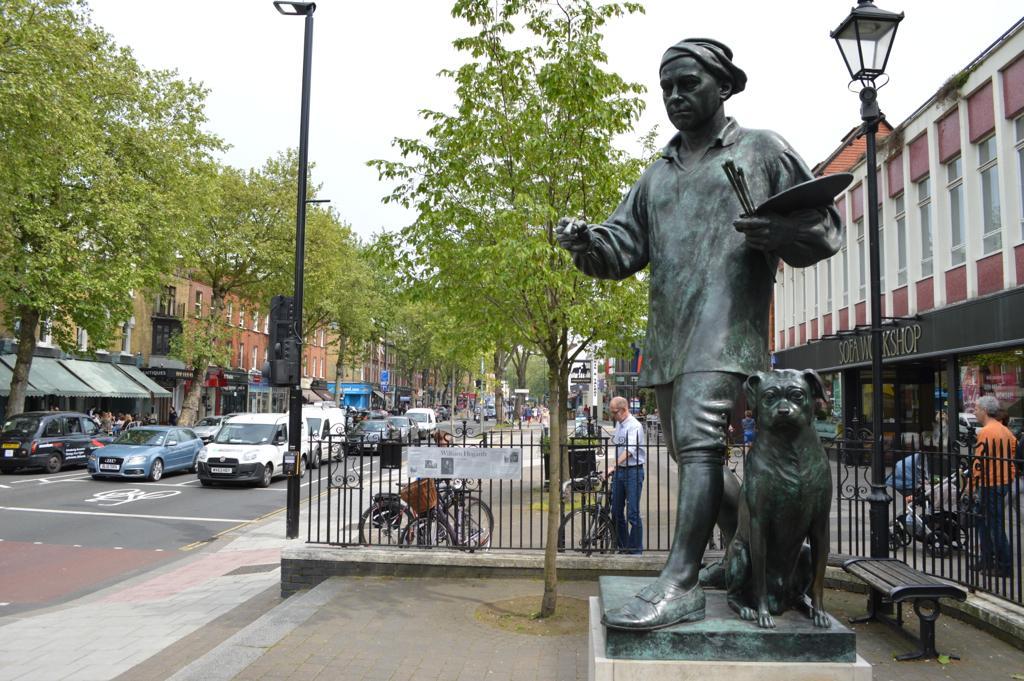Can you describe this image briefly? In the foreground of this picture, there is a sculpture. In the background, there are poles, a bench, railing, trees, bicycles, vehicles, buildings and the sky. 